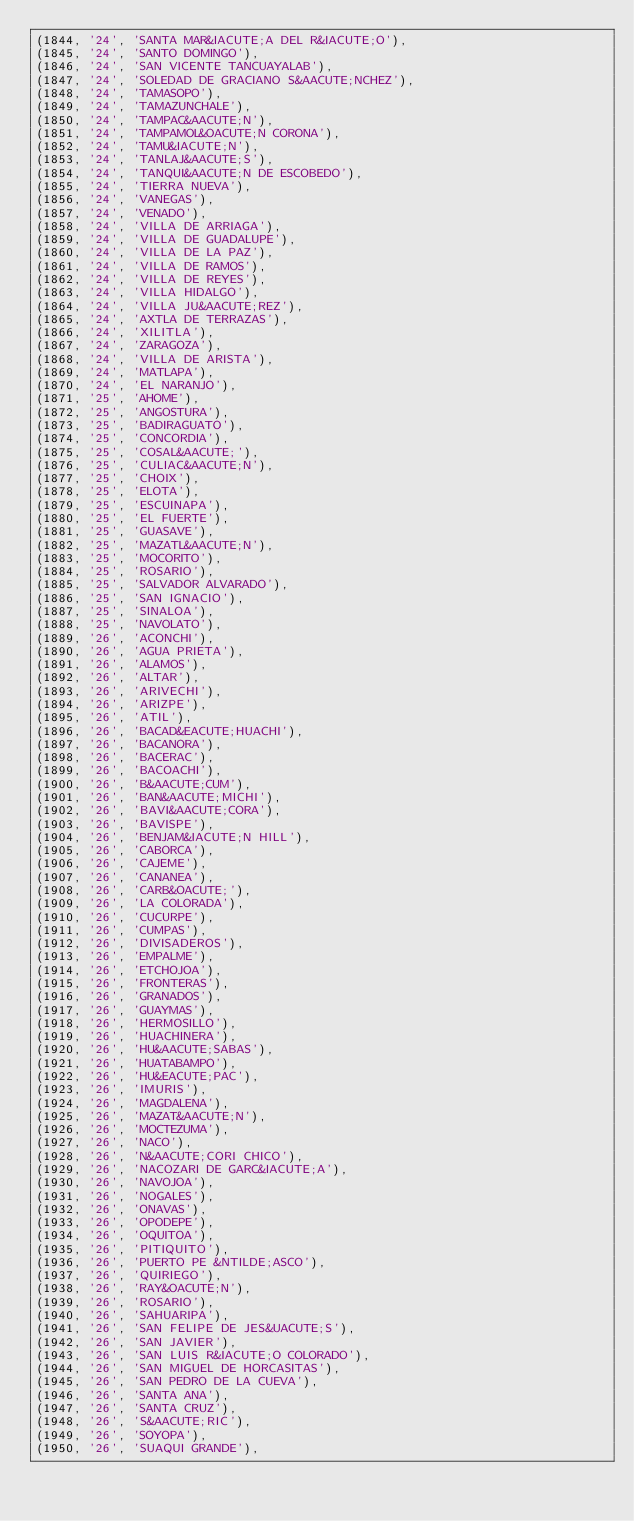Convert code to text. <code><loc_0><loc_0><loc_500><loc_500><_SQL_>(1844, '24', 'SANTA MAR&IACUTE;A DEL R&IACUTE;O'),
(1845, '24', 'SANTO DOMINGO'),
(1846, '24', 'SAN VICENTE TANCUAYALAB'),
(1847, '24', 'SOLEDAD DE GRACIANO S&AACUTE;NCHEZ'),
(1848, '24', 'TAMASOPO'),
(1849, '24', 'TAMAZUNCHALE'),
(1850, '24', 'TAMPAC&AACUTE;N'),
(1851, '24', 'TAMPAMOL&OACUTE;N CORONA'),
(1852, '24', 'TAMU&IACUTE;N'),
(1853, '24', 'TANLAJ&AACUTE;S'),
(1854, '24', 'TANQUI&AACUTE;N DE ESCOBEDO'),
(1855, '24', 'TIERRA NUEVA'),
(1856, '24', 'VANEGAS'),
(1857, '24', 'VENADO'),
(1858, '24', 'VILLA DE ARRIAGA'),
(1859, '24', 'VILLA DE GUADALUPE'),
(1860, '24', 'VILLA DE LA PAZ'),
(1861, '24', 'VILLA DE RAMOS'),
(1862, '24', 'VILLA DE REYES'),
(1863, '24', 'VILLA HIDALGO'),
(1864, '24', 'VILLA JU&AACUTE;REZ'),
(1865, '24', 'AXTLA DE TERRAZAS'),
(1866, '24', 'XILITLA'),
(1867, '24', 'ZARAGOZA'),
(1868, '24', 'VILLA DE ARISTA'),
(1869, '24', 'MATLAPA'),
(1870, '24', 'EL NARANJO'),
(1871, '25', 'AHOME'),
(1872, '25', 'ANGOSTURA'),
(1873, '25', 'BADIRAGUATO'),
(1874, '25', 'CONCORDIA'),
(1875, '25', 'COSAL&AACUTE;'),
(1876, '25', 'CULIAC&AACUTE;N'),
(1877, '25', 'CHOIX'),
(1878, '25', 'ELOTA'),
(1879, '25', 'ESCUINAPA'),
(1880, '25', 'EL FUERTE'),
(1881, '25', 'GUASAVE'),
(1882, '25', 'MAZATL&AACUTE;N'),
(1883, '25', 'MOCORITO'),
(1884, '25', 'ROSARIO'),
(1885, '25', 'SALVADOR ALVARADO'),
(1886, '25', 'SAN IGNACIO'),
(1887, '25', 'SINALOA'),
(1888, '25', 'NAVOLATO'),
(1889, '26', 'ACONCHI'),
(1890, '26', 'AGUA PRIETA'),
(1891, '26', 'ALAMOS'),
(1892, '26', 'ALTAR'),
(1893, '26', 'ARIVECHI'),
(1894, '26', 'ARIZPE'),
(1895, '26', 'ATIL'),
(1896, '26', 'BACAD&EACUTE;HUACHI'),
(1897, '26', 'BACANORA'),
(1898, '26', 'BACERAC'),
(1899, '26', 'BACOACHI'),
(1900, '26', 'B&AACUTE;CUM'),
(1901, '26', 'BAN&AACUTE;MICHI'),
(1902, '26', 'BAVI&AACUTE;CORA'),
(1903, '26', 'BAVISPE'),
(1904, '26', 'BENJAM&IACUTE;N HILL'),
(1905, '26', 'CABORCA'),
(1906, '26', 'CAJEME'),
(1907, '26', 'CANANEA'),
(1908, '26', 'CARB&OACUTE;'),
(1909, '26', 'LA COLORADA'),
(1910, '26', 'CUCURPE'),
(1911, '26', 'CUMPAS'),
(1912, '26', 'DIVISADEROS'),
(1913, '26', 'EMPALME'),
(1914, '26', 'ETCHOJOA'),
(1915, '26', 'FRONTERAS'),
(1916, '26', 'GRANADOS'),
(1917, '26', 'GUAYMAS'),
(1918, '26', 'HERMOSILLO'),
(1919, '26', 'HUACHINERA'),
(1920, '26', 'HU&AACUTE;SABAS'),
(1921, '26', 'HUATABAMPO'),
(1922, '26', 'HU&EACUTE;PAC'),
(1923, '26', 'IMURIS'),
(1924, '26', 'MAGDALENA'),
(1925, '26', 'MAZAT&AACUTE;N'),
(1926, '26', 'MOCTEZUMA'),
(1927, '26', 'NACO'),
(1928, '26', 'N&AACUTE;CORI CHICO'),
(1929, '26', 'NACOZARI DE GARC&IACUTE;A'),
(1930, '26', 'NAVOJOA'),
(1931, '26', 'NOGALES'),
(1932, '26', 'ONAVAS'),
(1933, '26', 'OPODEPE'),
(1934, '26', 'OQUITOA'),
(1935, '26', 'PITIQUITO'),
(1936, '26', 'PUERTO PE &NTILDE;ASCO'),
(1937, '26', 'QUIRIEGO'),
(1938, '26', 'RAY&OACUTE;N'),
(1939, '26', 'ROSARIO'),
(1940, '26', 'SAHUARIPA'),
(1941, '26', 'SAN FELIPE DE JES&UACUTE;S'),
(1942, '26', 'SAN JAVIER'),
(1943, '26', 'SAN LUIS R&IACUTE;O COLORADO'),
(1944, '26', 'SAN MIGUEL DE HORCASITAS'),
(1945, '26', 'SAN PEDRO DE LA CUEVA'),
(1946, '26', 'SANTA ANA'),
(1947, '26', 'SANTA CRUZ'),
(1948, '26', 'S&AACUTE;RIC'),
(1949, '26', 'SOYOPA'),
(1950, '26', 'SUAQUI GRANDE'),</code> 